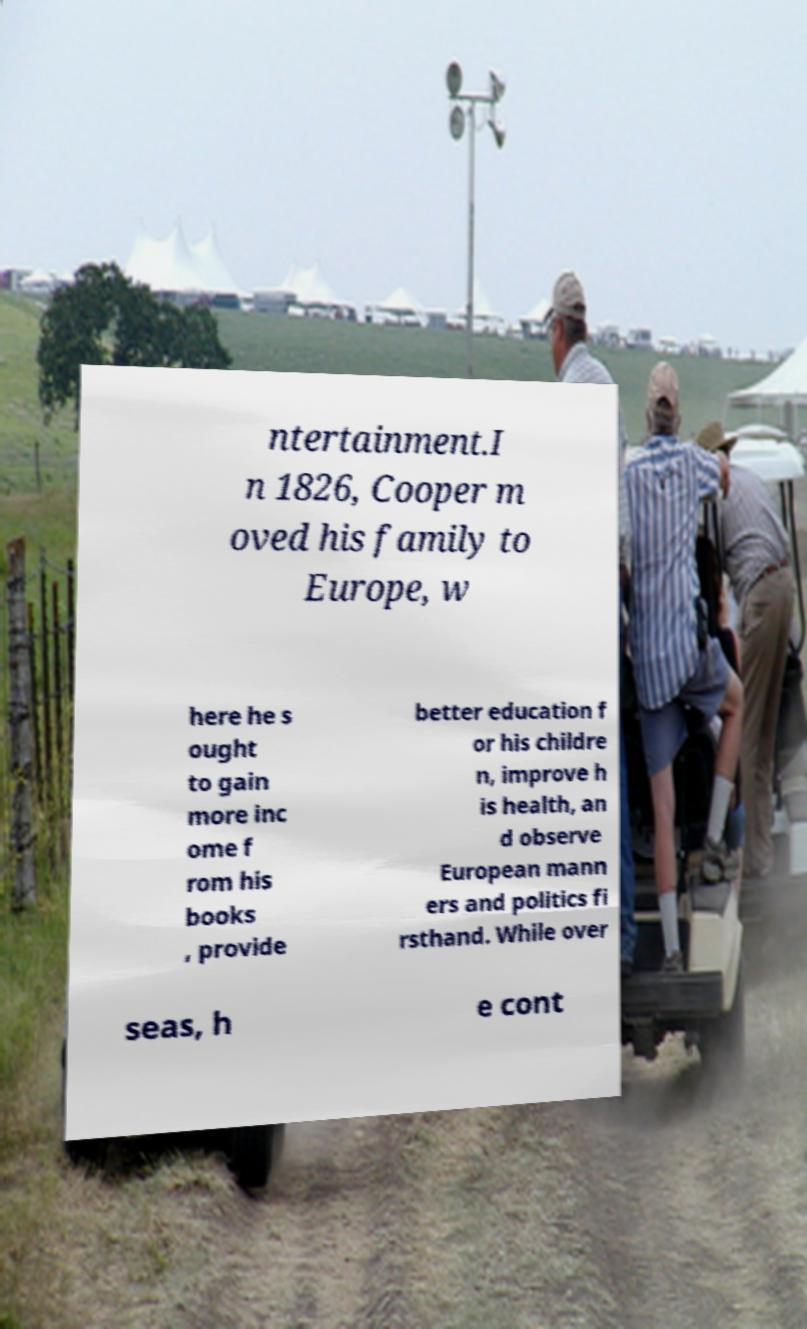For documentation purposes, I need the text within this image transcribed. Could you provide that? ntertainment.I n 1826, Cooper m oved his family to Europe, w here he s ought to gain more inc ome f rom his books , provide better education f or his childre n, improve h is health, an d observe European mann ers and politics fi rsthand. While over seas, h e cont 